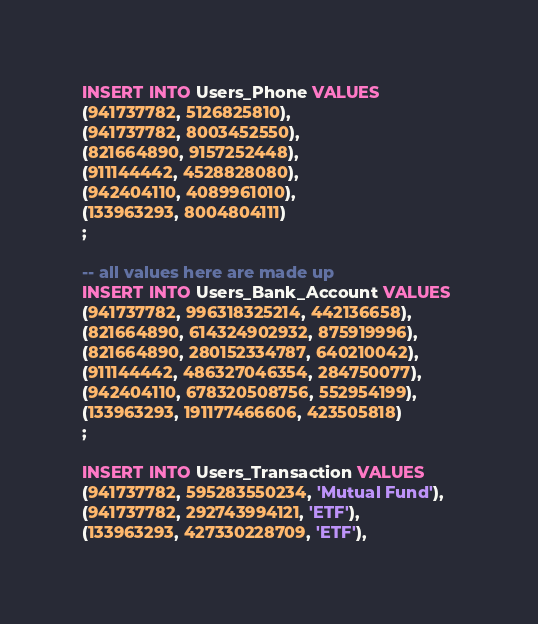<code> <loc_0><loc_0><loc_500><loc_500><_SQL_>INSERT INTO Users_Phone VALUES 
(941737782, 5126825810),
(941737782, 8003452550),
(821664890, 9157252448),
(911144442, 4528828080),
(942404110, 4089961010),
(133963293, 8004804111)
;

-- all values here are made up
INSERT INTO Users_Bank_Account VALUES 
(941737782, 996318325214, 442136658),
(821664890, 614324902932, 875919996),
(821664890, 280152334787, 640210042),
(911144442, 486327046354, 284750077),
(942404110, 678320508756, 552954199),
(133963293, 191177466606, 423505818)
;

INSERT INTO Users_Transaction VALUES 
(941737782, 595283550234, 'Mutual Fund'),
(941737782, 292743994121, 'ETF'),
(133963293, 427330228709, 'ETF'),</code> 